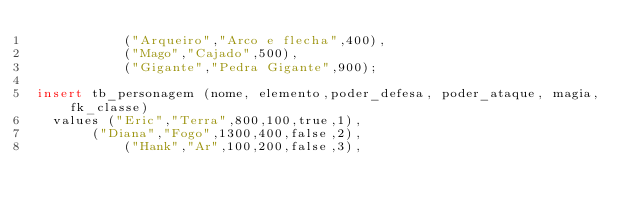<code> <loc_0><loc_0><loc_500><loc_500><_SQL_>           ("Arqueiro","Arco e flecha",400),
           ("Mago","Cajado",500),
           ("Gigante","Pedra Gigante",900);	
           
insert tb_personagem (nome, elemento,poder_defesa, poder_ataque, magia, fk_classe)
	values ("Eric","Terra",800,100,true,1),
		   ("Diana","Fogo",1300,400,false,2),
           ("Hank","Ar",100,200,false,3),</code> 